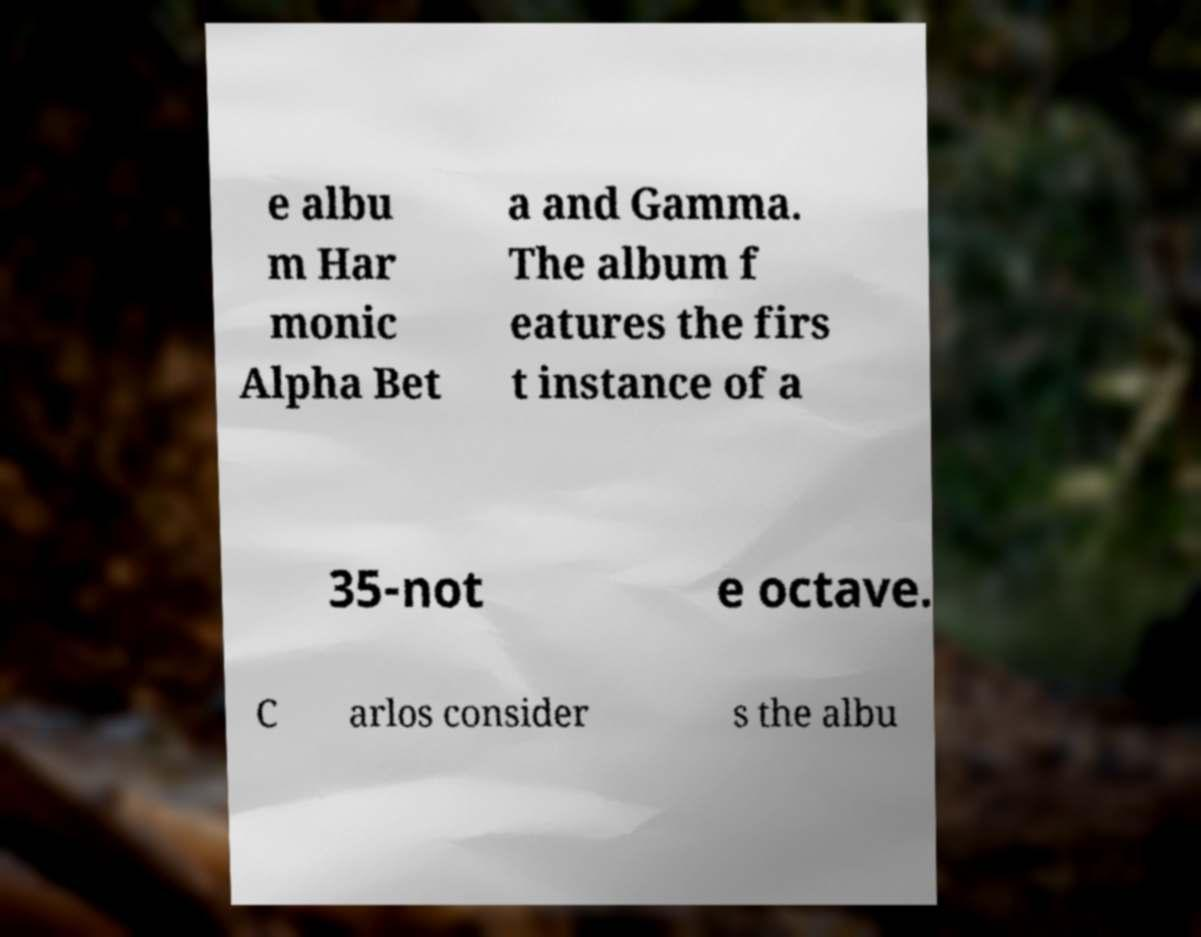Can you accurately transcribe the text from the provided image for me? e albu m Har monic Alpha Bet a and Gamma. The album f eatures the firs t instance of a 35-not e octave. C arlos consider s the albu 